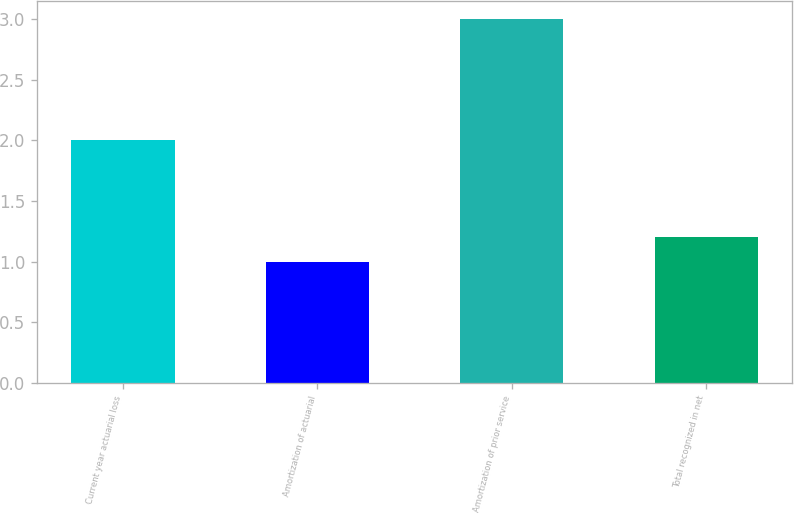Convert chart to OTSL. <chart><loc_0><loc_0><loc_500><loc_500><bar_chart><fcel>Current year actuarial loss<fcel>Amortization of actuarial<fcel>Amortization of prior service<fcel>Total recognized in net<nl><fcel>2<fcel>1<fcel>3<fcel>1.2<nl></chart> 